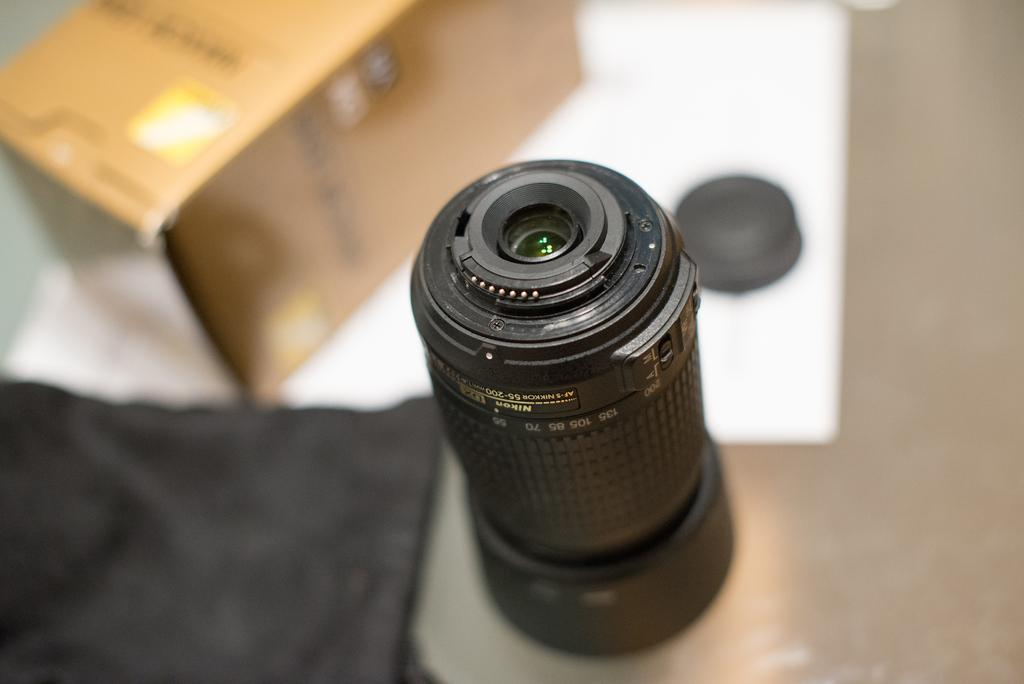What is the main subject of the image? The main subject of the image is a camera lens. Where is the camera lens located in the image? The camera lens is in the middle of the image. What else can be seen on the left side of the image? There is a box on the left side of the image. What type of flowers can be seen in the garden in the image? There is no garden present in the image, so it is not possible to answer that question. 